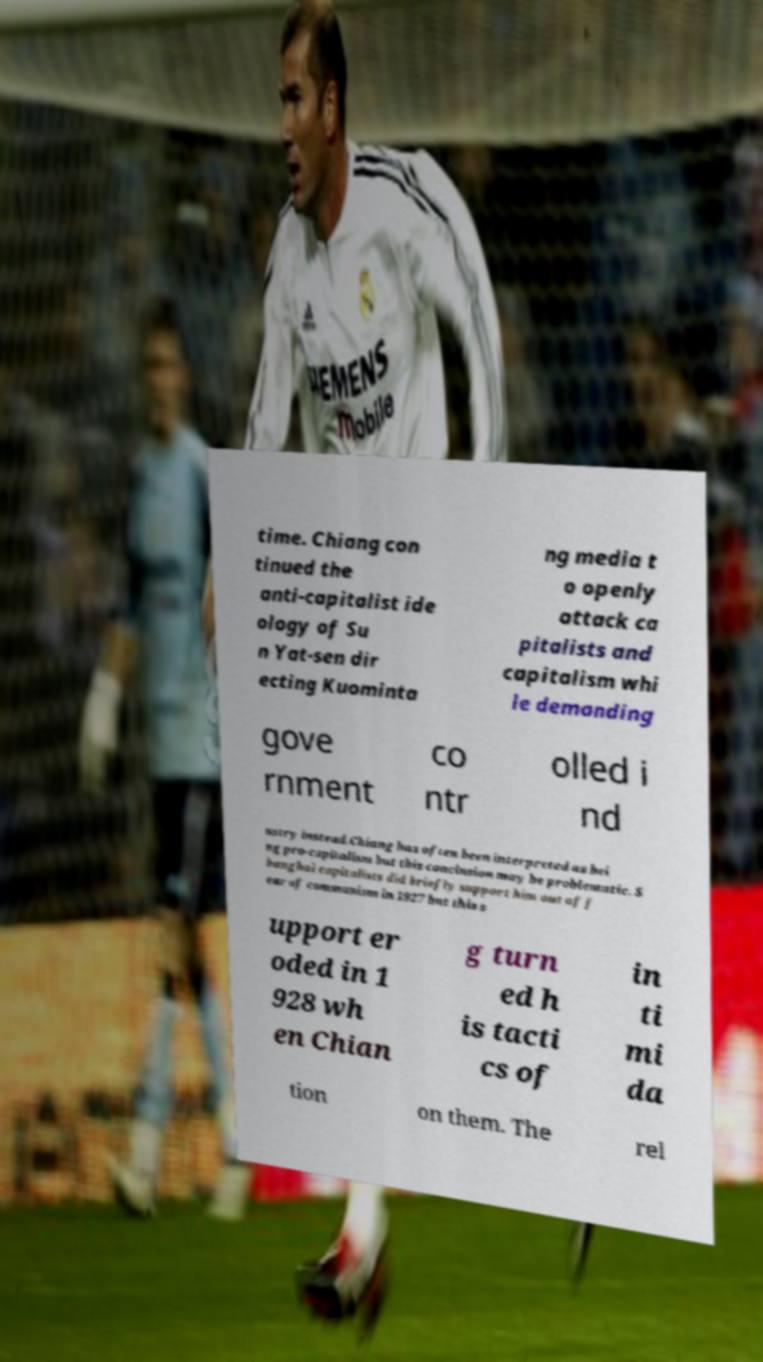Could you assist in decoding the text presented in this image and type it out clearly? time. Chiang con tinued the anti-capitalist ide ology of Su n Yat-sen dir ecting Kuominta ng media t o openly attack ca pitalists and capitalism whi le demanding gove rnment co ntr olled i nd ustry instead.Chiang has often been interpreted as bei ng pro-capitalism but this conclusion may be problematic. S hanghai capitalists did briefly support him out of f ear of communism in 1927 but this s upport er oded in 1 928 wh en Chian g turn ed h is tacti cs of in ti mi da tion on them. The rel 